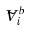<formula> <loc_0><loc_0><loc_500><loc_500>\tilde { V } _ { i } ^ { b }</formula> 